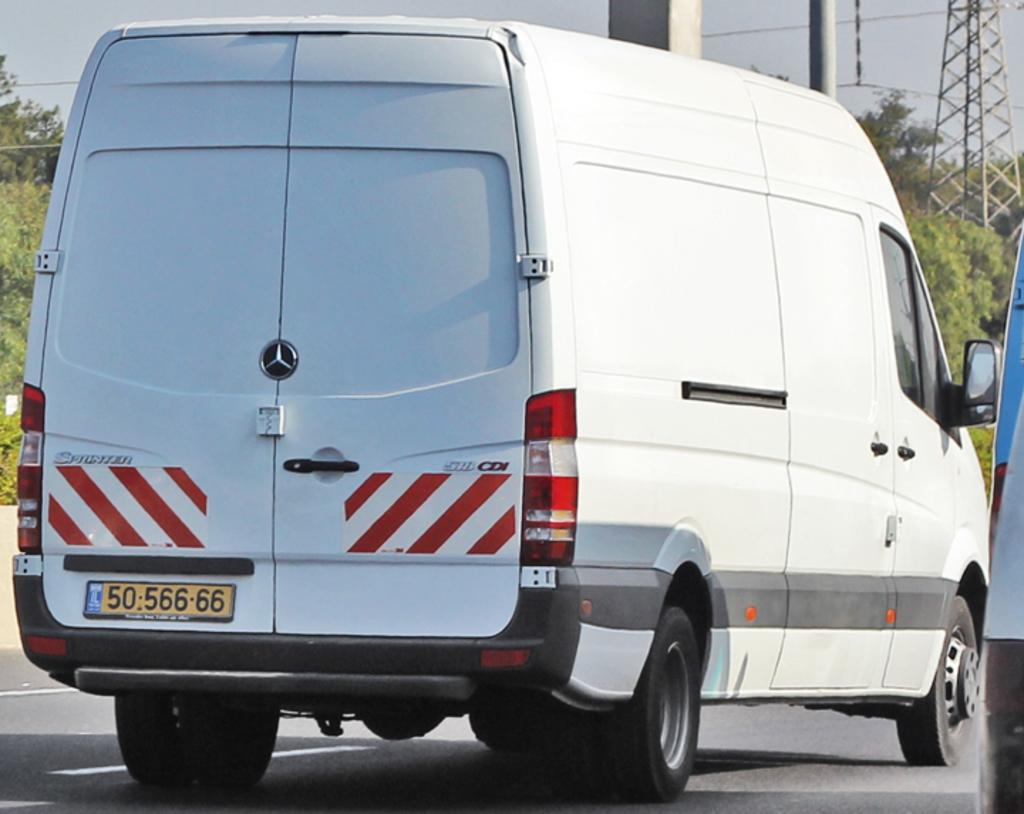What is happening in the center of the image? There are vehicles moving on the road in the center of the image. What can be seen in the background of the image? There are poles and trees in the background of the image. How would you describe the sky in the image? The sky is cloudy in the background of the image. Can you see any fish swimming in the image? There are no fish visible in the image; it features vehicles on a road and elements in the background. 